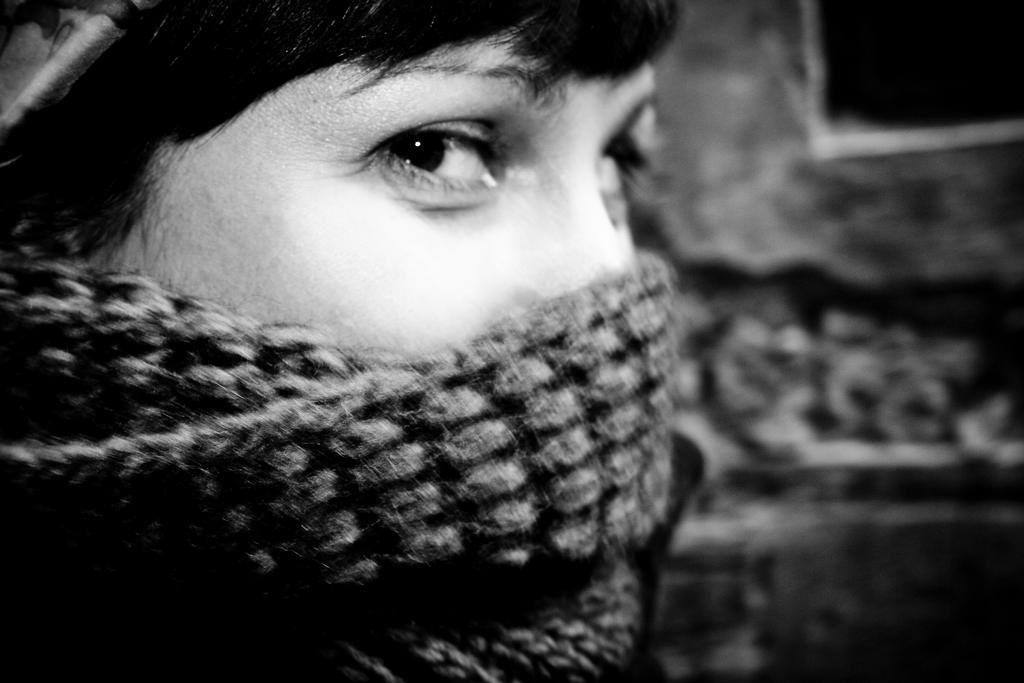What is located on the left side of the image? There is a person on the left side of the image. What is the person wearing on their face? The person is wearing a mask. How much of the person's face is covered by the mask? The mask is partially covering the person's face. Can you describe the background of the image? The background of the image is blurred. How many plates are stacked on the person's head in the image? There are no plates visible in the image; the person is wearing a mask. What number is written on the person's shirt in the image? There is no number visible on the person's shirt in the image. 